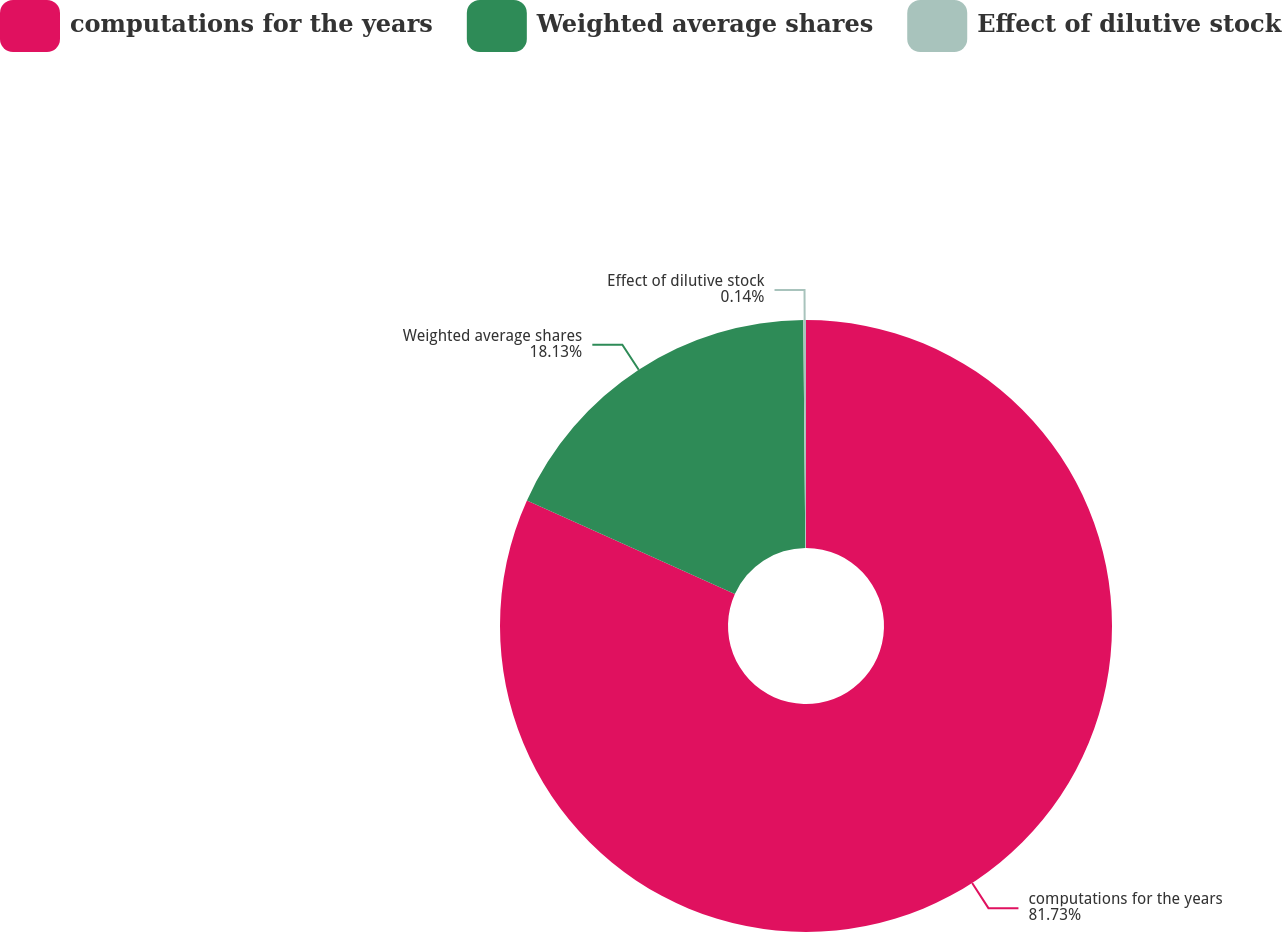Convert chart. <chart><loc_0><loc_0><loc_500><loc_500><pie_chart><fcel>computations for the years<fcel>Weighted average shares<fcel>Effect of dilutive stock<nl><fcel>81.73%<fcel>18.13%<fcel>0.14%<nl></chart> 